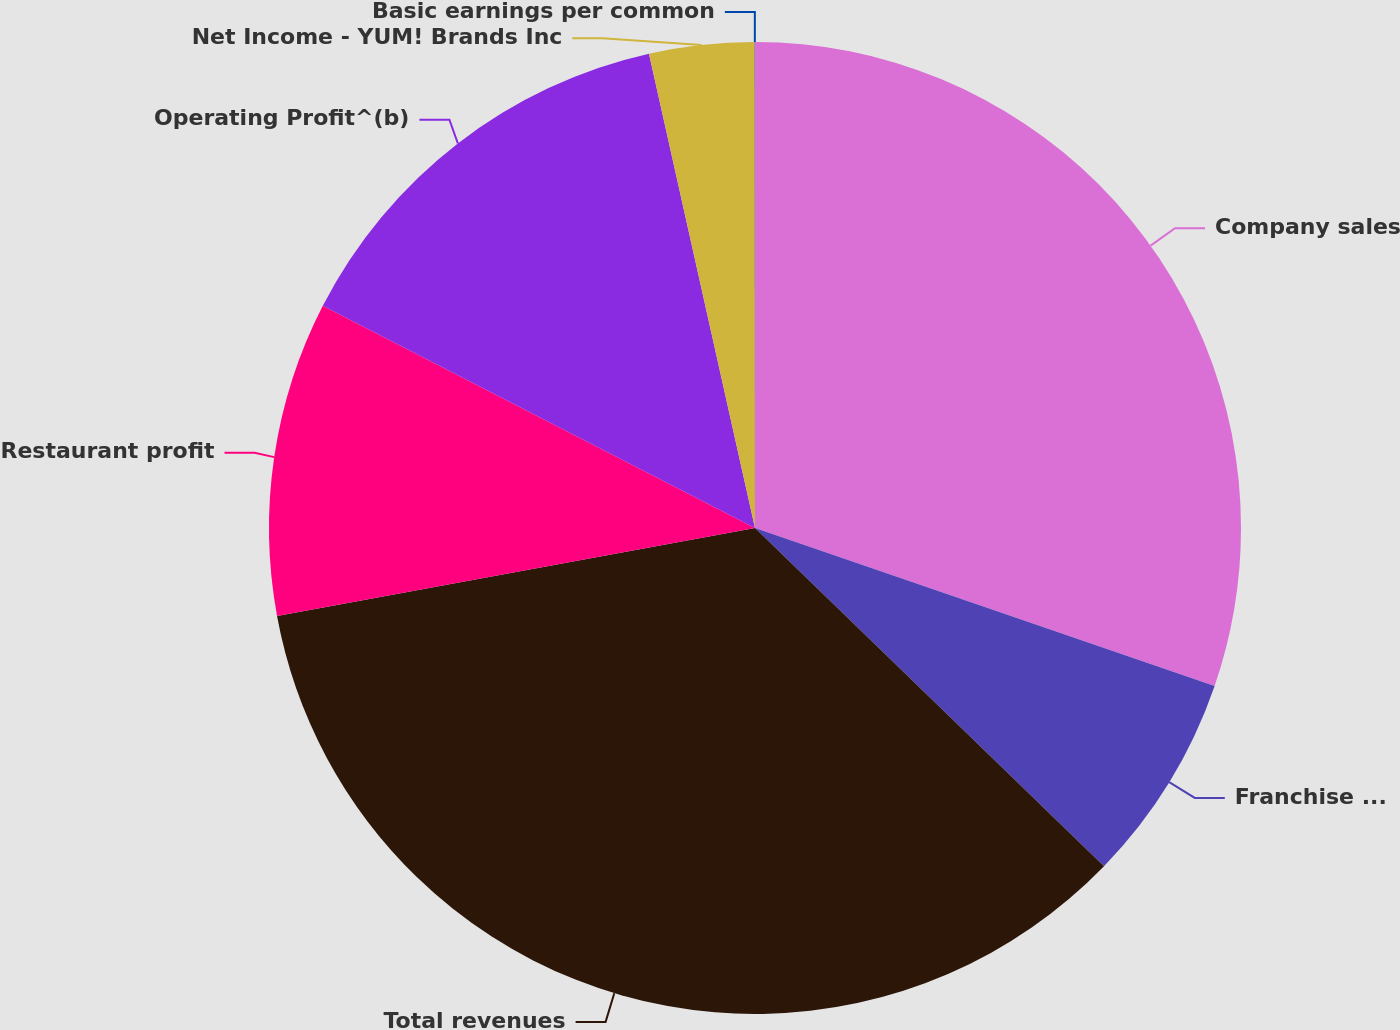Convert chart. <chart><loc_0><loc_0><loc_500><loc_500><pie_chart><fcel>Company sales<fcel>Franchise and license fees and<fcel>Total revenues<fcel>Restaurant profit<fcel>Operating Profit^(b)<fcel>Net Income - YUM! Brands Inc<fcel>Basic earnings per common<nl><fcel>30.27%<fcel>6.98%<fcel>34.85%<fcel>10.46%<fcel>13.94%<fcel>3.49%<fcel>0.01%<nl></chart> 